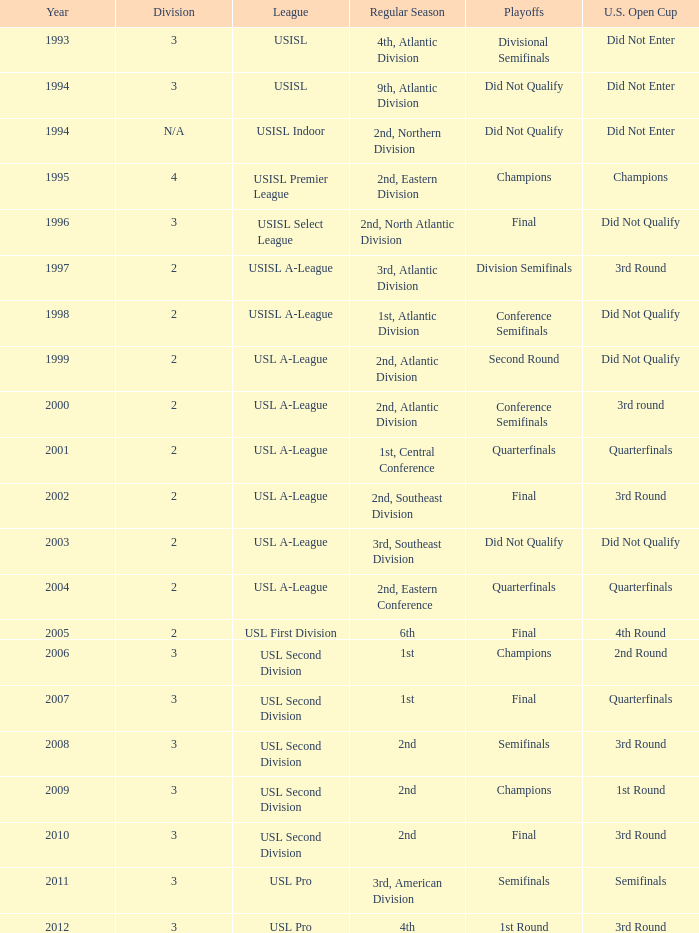What's the u.s. open cup status for regular season of 4th, atlantic division  Did Not Enter. 